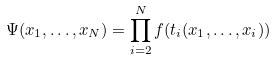<formula> <loc_0><loc_0><loc_500><loc_500>\Psi ( x _ { 1 } , \dots , x _ { N } ) = \prod _ { i = 2 } ^ { N } f ( t _ { i } ( x _ { 1 } , \dots , x _ { i } ) )</formula> 